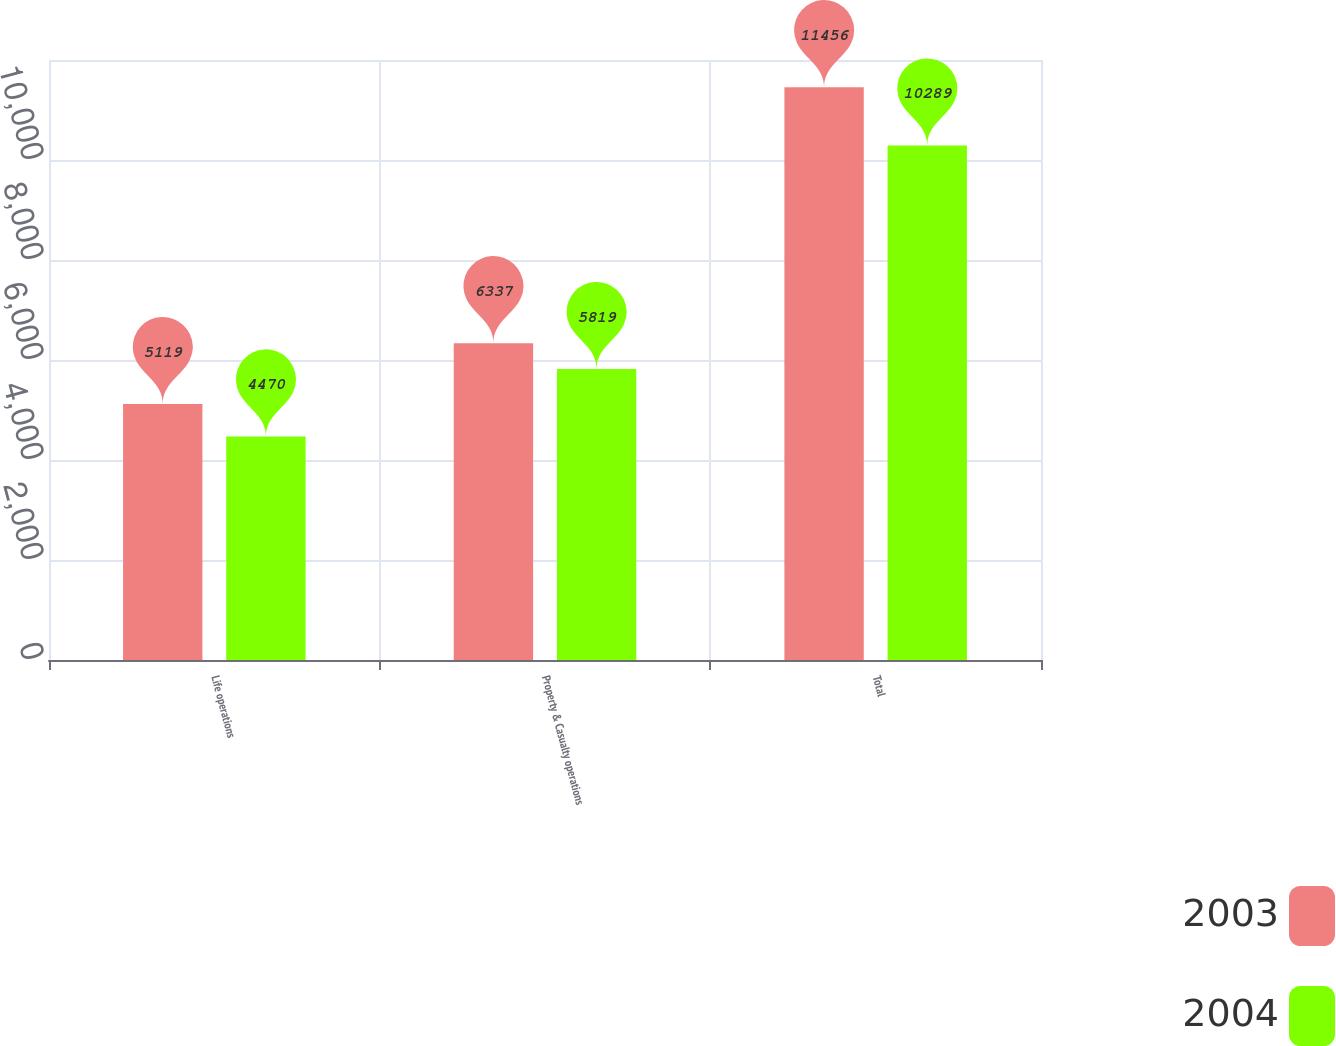<chart> <loc_0><loc_0><loc_500><loc_500><stacked_bar_chart><ecel><fcel>Life operations<fcel>Property & Casualty operations<fcel>Total<nl><fcel>2003<fcel>5119<fcel>6337<fcel>11456<nl><fcel>2004<fcel>4470<fcel>5819<fcel>10289<nl></chart> 